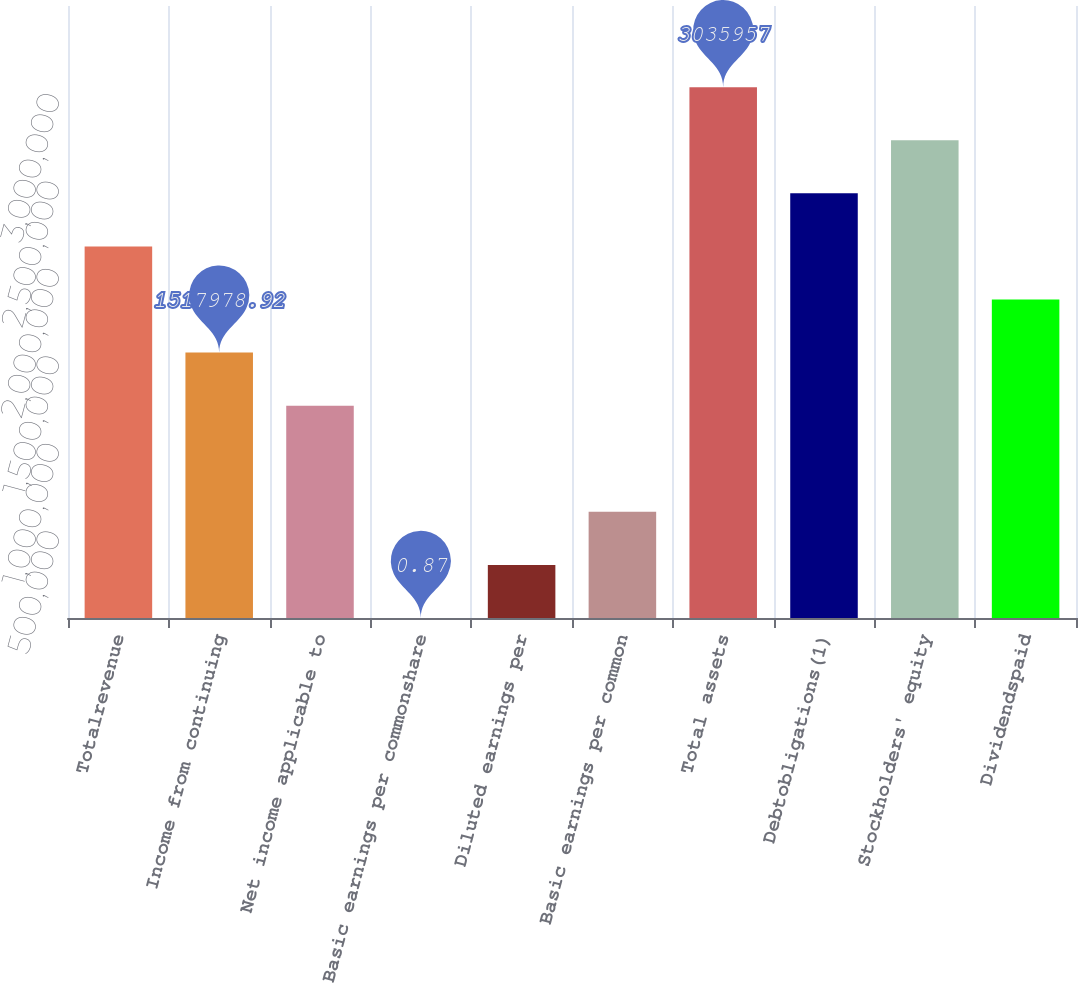<chart> <loc_0><loc_0><loc_500><loc_500><bar_chart><fcel>Totalrevenue<fcel>Income from continuing<fcel>Net income applicable to<fcel>Basic earnings per commonshare<fcel>Diluted earnings per<fcel>Basic earnings per common<fcel>Total assets<fcel>Debtobligations(1)<fcel>Stockholders' equity<fcel>Dividendspaid<nl><fcel>2.12517e+06<fcel>1.51798e+06<fcel>1.21438e+06<fcel>0.87<fcel>303596<fcel>607192<fcel>3.03596e+06<fcel>2.42877e+06<fcel>2.73236e+06<fcel>1.82157e+06<nl></chart> 